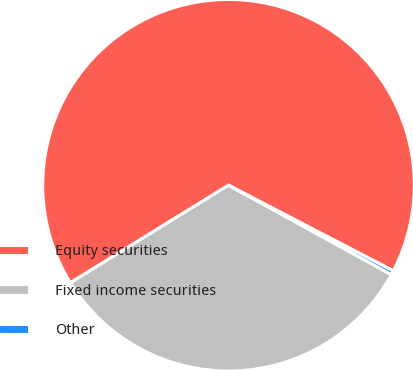<chart> <loc_0><loc_0><loc_500><loc_500><pie_chart><fcel>Equity securities<fcel>Fixed income securities<fcel>Other<nl><fcel>66.43%<fcel>33.21%<fcel>0.36%<nl></chart> 